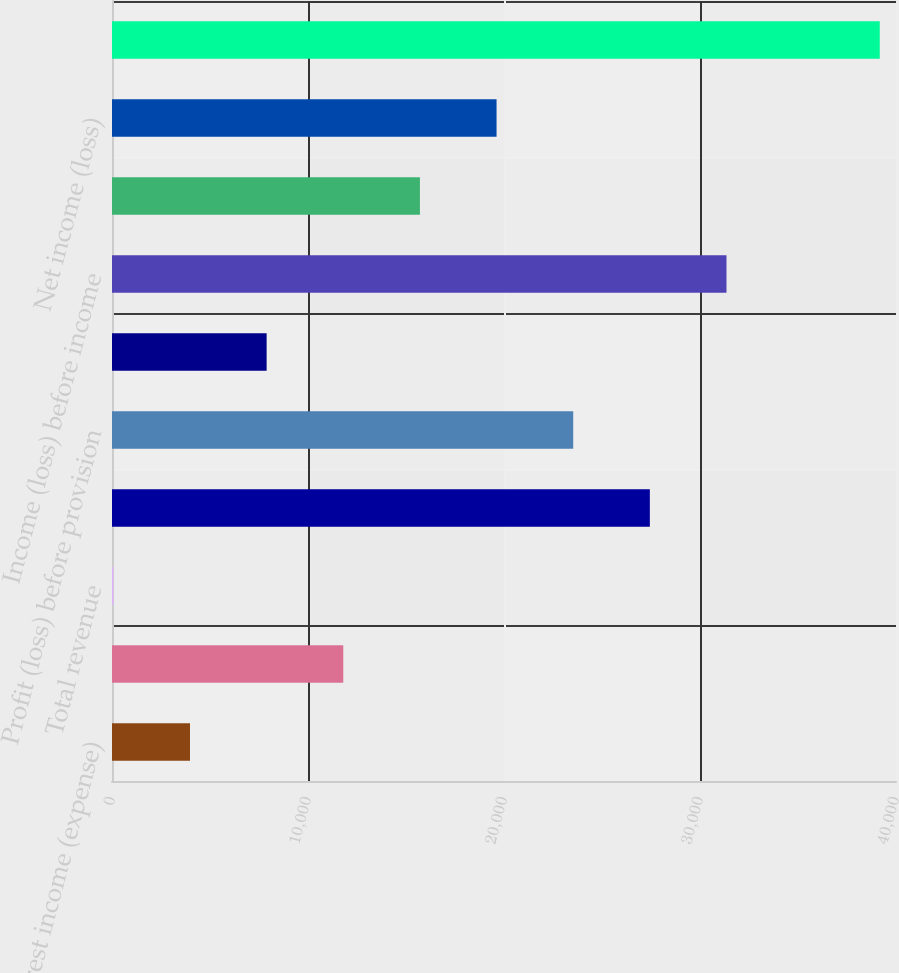Convert chart. <chart><loc_0><loc_0><loc_500><loc_500><bar_chart><fcel>Net interest income (expense)<fcel>Noninterest income<fcel>Total revenue<fcel>Noninterest expense<fcel>Profit (loss) before provision<fcel>Provision for credit losses<fcel>Income (loss) before income<fcel>Income tax expense (benefit)<fcel>Net income (loss)<fcel>Total Average Assets<nl><fcel>3979.3<fcel>11799.9<fcel>69<fcel>27441.1<fcel>23530.8<fcel>7889.6<fcel>31351.4<fcel>15710.2<fcel>19620.5<fcel>39172<nl></chart> 